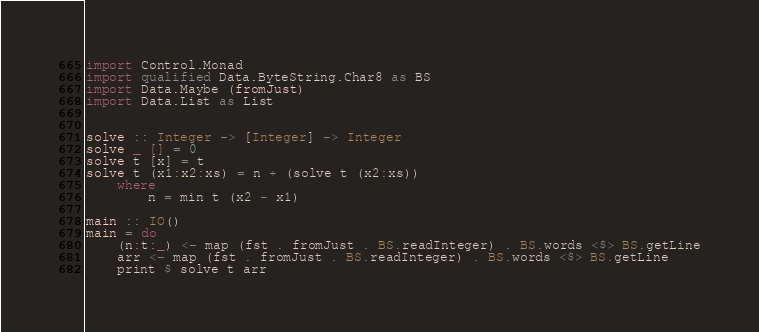Convert code to text. <code><loc_0><loc_0><loc_500><loc_500><_Haskell_>import Control.Monad
import qualified Data.ByteString.Char8 as BS
import Data.Maybe (fromJust)
import Data.List as List


solve :: Integer -> [Integer] -> Integer
solve _ [] = 0
solve t [x] = t
solve t (x1:x2:xs) = n + (solve t (x2:xs))
    where
        n = min t (x2 - x1)

main :: IO()
main = do
    (n:t:_) <- map (fst . fromJust . BS.readInteger) . BS.words <$> BS.getLine
    arr <- map (fst . fromJust . BS.readInteger) . BS.words <$> BS.getLine
    print $ solve t arr   
</code> 